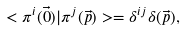Convert formula to latex. <formula><loc_0><loc_0><loc_500><loc_500>< \pi ^ { i } ( \vec { 0 } ) | \pi ^ { j } ( \vec { p } ) > = \delta ^ { i j } \delta ( \vec { p } ) ,</formula> 